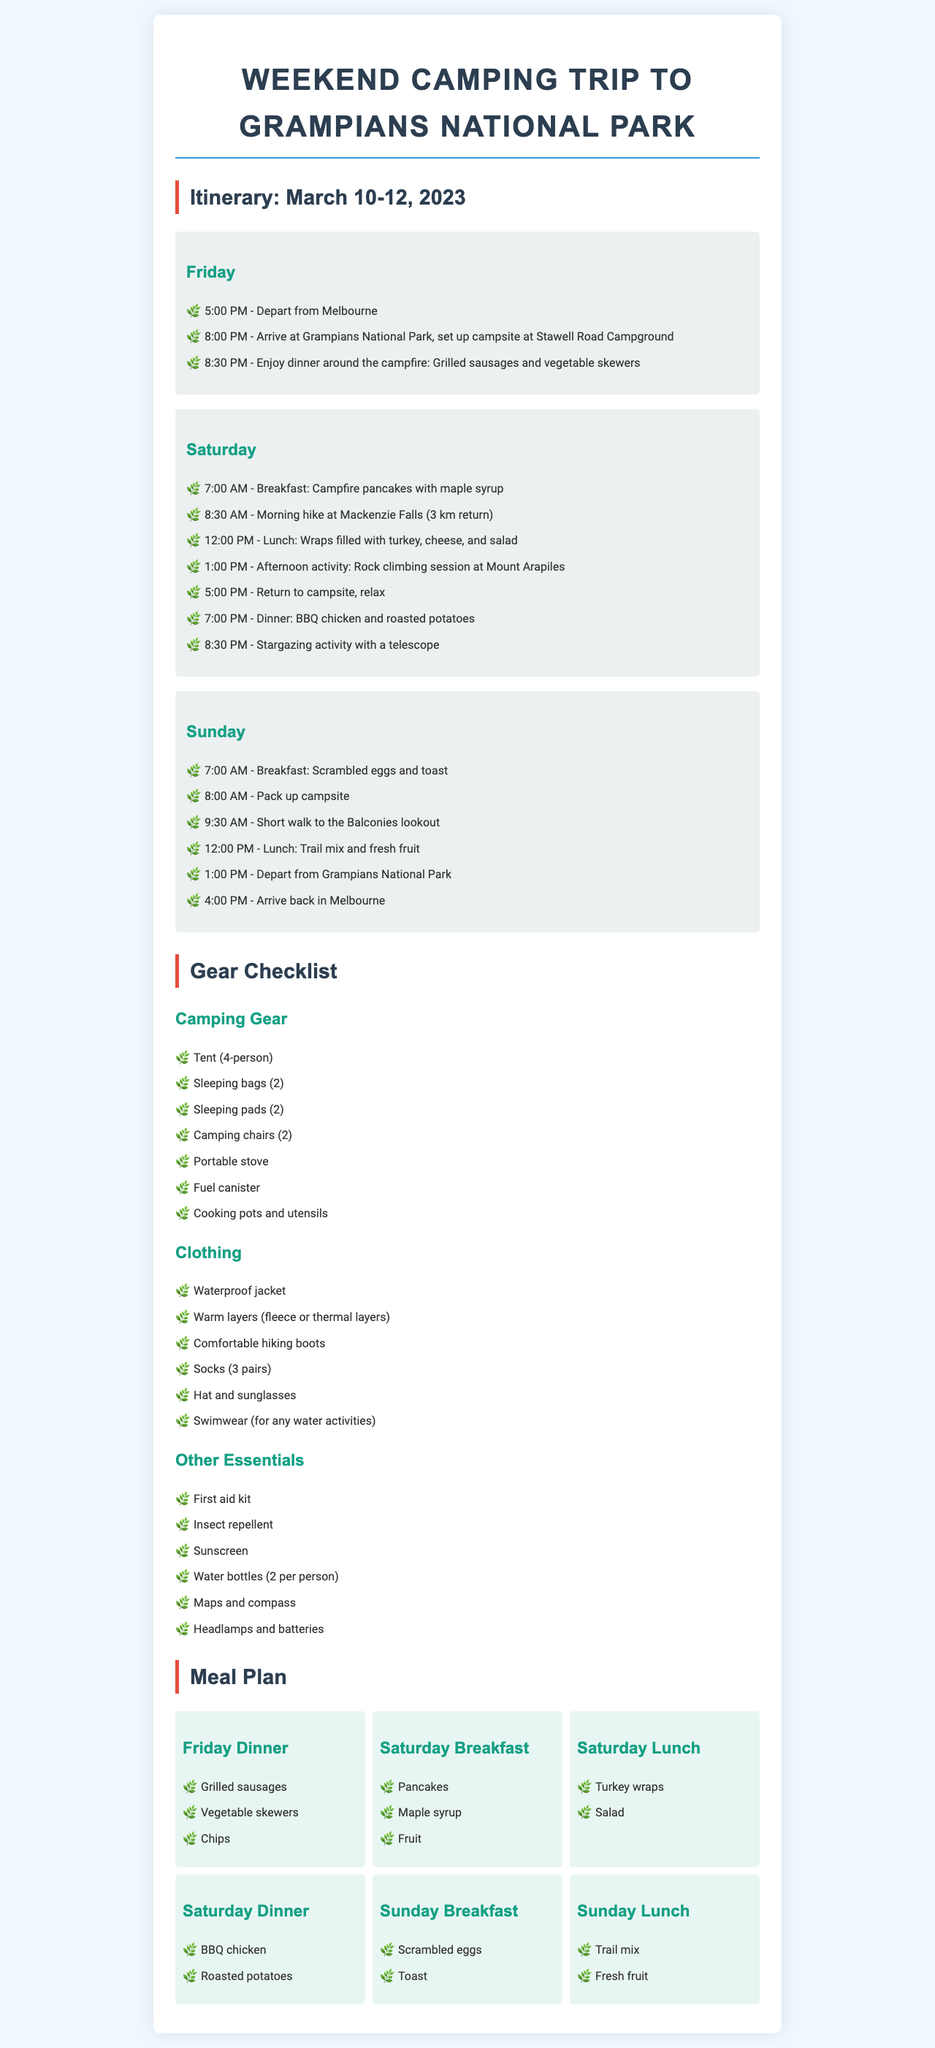What is the departure time from Melbourne? The itinerary states the departure time is at 5:00 PM on Friday.
Answer: 5:00 PM How many sleeping bags are required? The gear checklist specifies that 2 sleeping bags are needed for the trip.
Answer: 2 What meal is planned for Saturday lunch? According to the meal plan, the meal for Saturday lunch is wraps filled with turkey, cheese, and salad.
Answer: Turkey wraps When does the group arrive back in Melbourne? The itinerary indicates that the group arrives back in Melbourne at 4:00 PM on Sunday.
Answer: 4:00 PM What activity is scheduled for Saturday afternoon? The document notes that rock climbing at Mount Arapiles is the scheduled afternoon activity on Saturday.
Answer: Rock climbing What is the total number of meals planned for the trip? The meal plan includes 6 meals across the Friday to Sunday itinerary.
Answer: 6 meals What type of camping gear is mentioned? The gear checklist lists various items including tent, sleeping bags, and camping chairs, which are all essential camping gear.
Answer: Tent What time is stargazing scheduled on Saturday? The itinerary mentions that stargazing is scheduled at 8:30 PM on Saturday night.
Answer: 8:30 PM 